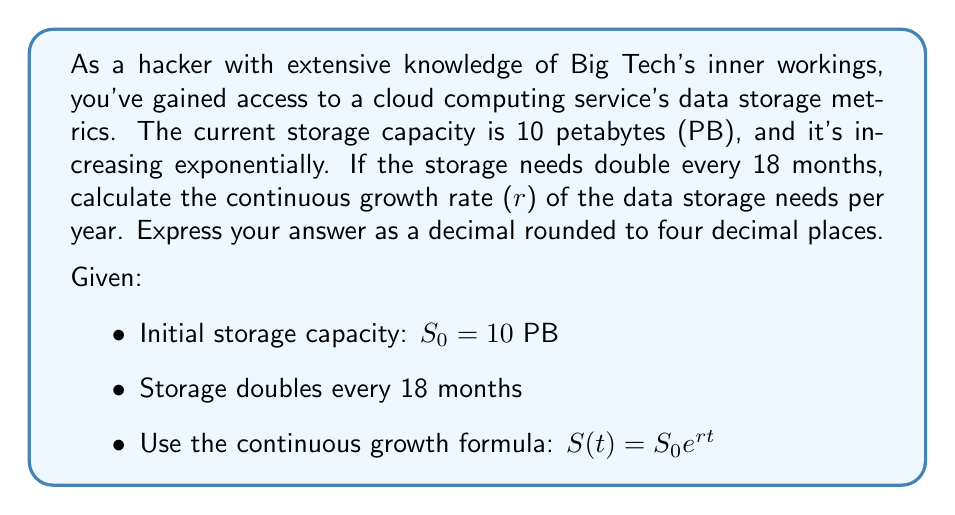Show me your answer to this math problem. To solve this problem, we'll use the continuous growth formula and the given information:

1) The continuous growth formula is:
   $S(t) = S_0 e^{rt}$

2) We know that the storage doubles every 18 months. Let's express this mathematically:
   $S(1.5) = 2S_0$

3) Substituting into the continuous growth formula:
   $2S_0 = S_0 e^{r(1.5)}$

4) Simplify by dividing both sides by $S_0$:
   $2 = e^{1.5r}$

5) Take the natural logarithm of both sides:
   $\ln(2) = 1.5r$

6) Solve for r:
   $r = \frac{\ln(2)}{1.5}$

7) Calculate:
   $r = \frac{0.693147...}{1.5} = 0.462098...$ per year

8) Round to four decimal places:
   $r \approx 0.4621$ per year
Answer: The continuous growth rate of the data storage needs is approximately 0.4621 per year. 